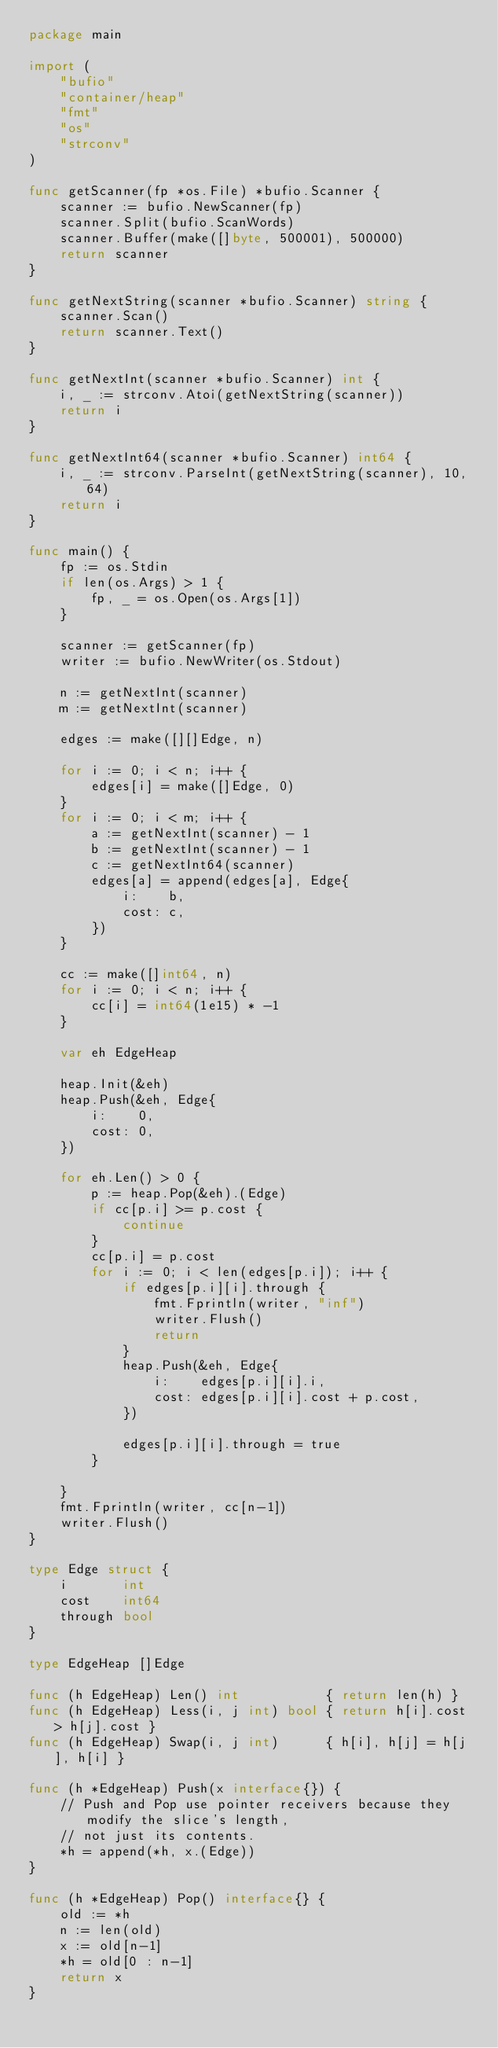<code> <loc_0><loc_0><loc_500><loc_500><_Go_>package main

import (
	"bufio"
	"container/heap"
	"fmt"
	"os"
	"strconv"
)

func getScanner(fp *os.File) *bufio.Scanner {
	scanner := bufio.NewScanner(fp)
	scanner.Split(bufio.ScanWords)
	scanner.Buffer(make([]byte, 500001), 500000)
	return scanner
}

func getNextString(scanner *bufio.Scanner) string {
	scanner.Scan()
	return scanner.Text()
}

func getNextInt(scanner *bufio.Scanner) int {
	i, _ := strconv.Atoi(getNextString(scanner))
	return i
}

func getNextInt64(scanner *bufio.Scanner) int64 {
	i, _ := strconv.ParseInt(getNextString(scanner), 10, 64)
	return i
}

func main() {
	fp := os.Stdin
	if len(os.Args) > 1 {
		fp, _ = os.Open(os.Args[1])
	}

	scanner := getScanner(fp)
	writer := bufio.NewWriter(os.Stdout)

	n := getNextInt(scanner)
	m := getNextInt(scanner)

	edges := make([][]Edge, n)

	for i := 0; i < n; i++ {
		edges[i] = make([]Edge, 0)
	}
	for i := 0; i < m; i++ {
		a := getNextInt(scanner) - 1
		b := getNextInt(scanner) - 1
		c := getNextInt64(scanner)
		edges[a] = append(edges[a], Edge{
			i:    b,
			cost: c,
		})
	}

	cc := make([]int64, n)
	for i := 0; i < n; i++ {
		cc[i] = int64(1e15) * -1
	}

	var eh EdgeHeap

	heap.Init(&eh)
	heap.Push(&eh, Edge{
		i:    0,
		cost: 0,
	})

	for eh.Len() > 0 {
		p := heap.Pop(&eh).(Edge)
		if cc[p.i] >= p.cost {
			continue
		}
		cc[p.i] = p.cost
		for i := 0; i < len(edges[p.i]); i++ {
			if edges[p.i][i].through {
				fmt.Fprintln(writer, "inf")
				writer.Flush()
				return
			}
			heap.Push(&eh, Edge{
				i:    edges[p.i][i].i,
				cost: edges[p.i][i].cost + p.cost,
			})

			edges[p.i][i].through = true
		}

	}
	fmt.Fprintln(writer, cc[n-1])
	writer.Flush()
}

type Edge struct {
	i       int
	cost    int64
	through bool
}

type EdgeHeap []Edge

func (h EdgeHeap) Len() int           { return len(h) }
func (h EdgeHeap) Less(i, j int) bool { return h[i].cost > h[j].cost }
func (h EdgeHeap) Swap(i, j int)      { h[i], h[j] = h[j], h[i] }

func (h *EdgeHeap) Push(x interface{}) {
	// Push and Pop use pointer receivers because they modify the slice's length,
	// not just its contents.
	*h = append(*h, x.(Edge))
}

func (h *EdgeHeap) Pop() interface{} {
	old := *h
	n := len(old)
	x := old[n-1]
	*h = old[0 : n-1]
	return x
}
</code> 